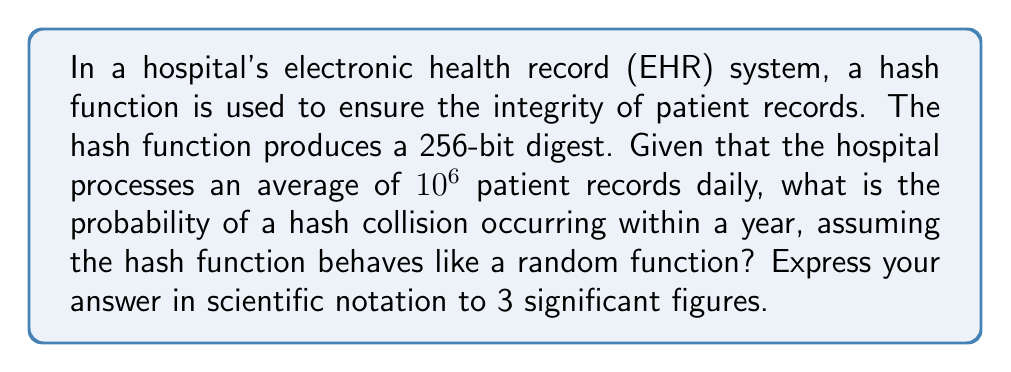Solve this math problem. Let's approach this step-by-step:

1) First, we need to calculate the number of patient records processed in a year:
   $365 \text{ days} \times 10^6 \text{ records/day} = 3.65 \times 10^8 \text{ records/year}$

2) The probability of a collision in a set of $n$ items, where each item is randomly assigned one of $m$ possible values, is approximately:

   $P(\text{collision}) \approx 1 - e^{-\frac{n^2}{2m}}$

   This is known as the birthday problem approximation.

3) In our case:
   $n = 3.65 \times 10^8$ (number of records per year)
   $m = 2^{256}$ (number of possible hash values for a 256-bit digest)

4) Substituting these values:

   $P(\text{collision}) \approx 1 - e^{-\frac{(3.65 \times 10^8)^2}{2 \times 2^{256}}}$

5) Simplify the exponent:
   $\frac{(3.65 \times 10^8)^2}{2 \times 2^{256}} = \frac{1.33225 \times 10^{17}}{2 \times 2^{256}} \approx 3.59 \times 10^{-60}$

6) Now our equation is:
   $P(\text{collision}) \approx 1 - e^{-3.59 \times 10^{-60}}$

7) Using the approximation $e^x \approx 1 + x$ for small $x$:
   $P(\text{collision}) \approx 1 - (1 - 3.59 \times 10^{-60}) = 3.59 \times 10^{-60}$

8) Rounding to 3 significant figures:
   $P(\text{collision}) \approx 3.59 \times 10^{-60}$
Answer: $3.59 \times 10^{-60}$ 